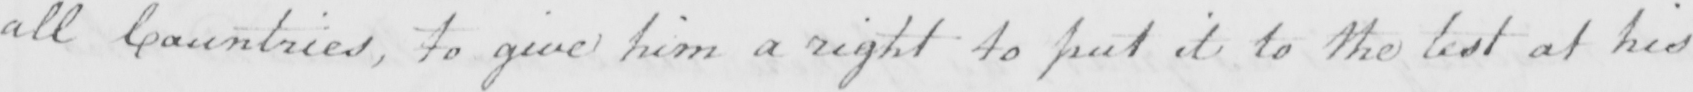What text is written in this handwritten line? all Countries , to give him a right to put it to the test at his 